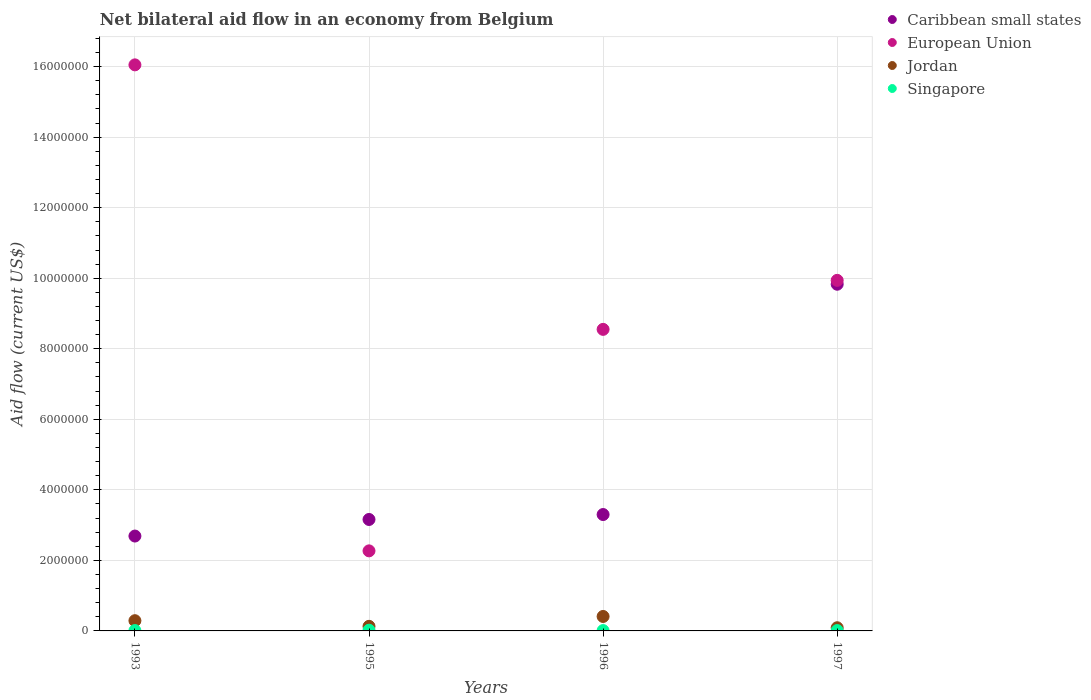What is the net bilateral aid flow in Caribbean small states in 1996?
Your answer should be compact. 3.30e+06. Across all years, what is the minimum net bilateral aid flow in Caribbean small states?
Keep it short and to the point. 2.69e+06. In which year was the net bilateral aid flow in Singapore maximum?
Keep it short and to the point. 1995. What is the total net bilateral aid flow in European Union in the graph?
Ensure brevity in your answer.  3.68e+07. What is the difference between the net bilateral aid flow in Singapore in 1996 and that in 1997?
Your answer should be compact. 0. What is the average net bilateral aid flow in European Union per year?
Offer a very short reply. 9.20e+06. In the year 1996, what is the difference between the net bilateral aid flow in Jordan and net bilateral aid flow in Singapore?
Keep it short and to the point. 4.00e+05. In how many years, is the net bilateral aid flow in Caribbean small states greater than 14800000 US$?
Keep it short and to the point. 0. What is the ratio of the net bilateral aid flow in Caribbean small states in 1993 to that in 1997?
Offer a very short reply. 0.27. What is the difference between the highest and the second highest net bilateral aid flow in Singapore?
Ensure brevity in your answer.  10000. What is the difference between the highest and the lowest net bilateral aid flow in Singapore?
Your response must be concise. 10000. In how many years, is the net bilateral aid flow in Singapore greater than the average net bilateral aid flow in Singapore taken over all years?
Your response must be concise. 1. Is it the case that in every year, the sum of the net bilateral aid flow in Jordan and net bilateral aid flow in Caribbean small states  is greater than the net bilateral aid flow in European Union?
Provide a short and direct response. No. Is the net bilateral aid flow in Jordan strictly greater than the net bilateral aid flow in Singapore over the years?
Offer a very short reply. Yes. Is the net bilateral aid flow in European Union strictly less than the net bilateral aid flow in Jordan over the years?
Offer a terse response. No. How many dotlines are there?
Offer a very short reply. 4. How many years are there in the graph?
Your answer should be compact. 4. What is the difference between two consecutive major ticks on the Y-axis?
Provide a short and direct response. 2.00e+06. Are the values on the major ticks of Y-axis written in scientific E-notation?
Provide a short and direct response. No. Does the graph contain any zero values?
Give a very brief answer. No. Where does the legend appear in the graph?
Your answer should be compact. Top right. How many legend labels are there?
Keep it short and to the point. 4. How are the legend labels stacked?
Provide a succinct answer. Vertical. What is the title of the graph?
Offer a very short reply. Net bilateral aid flow in an economy from Belgium. What is the label or title of the X-axis?
Give a very brief answer. Years. What is the Aid flow (current US$) in Caribbean small states in 1993?
Your answer should be very brief. 2.69e+06. What is the Aid flow (current US$) in European Union in 1993?
Ensure brevity in your answer.  1.60e+07. What is the Aid flow (current US$) in Jordan in 1993?
Provide a succinct answer. 2.90e+05. What is the Aid flow (current US$) of Singapore in 1993?
Provide a short and direct response. 10000. What is the Aid flow (current US$) in Caribbean small states in 1995?
Your answer should be compact. 3.16e+06. What is the Aid flow (current US$) in European Union in 1995?
Keep it short and to the point. 2.27e+06. What is the Aid flow (current US$) of Jordan in 1995?
Offer a terse response. 1.30e+05. What is the Aid flow (current US$) of Caribbean small states in 1996?
Give a very brief answer. 3.30e+06. What is the Aid flow (current US$) in European Union in 1996?
Provide a short and direct response. 8.55e+06. What is the Aid flow (current US$) in Caribbean small states in 1997?
Make the answer very short. 9.83e+06. What is the Aid flow (current US$) in European Union in 1997?
Give a very brief answer. 9.94e+06. What is the Aid flow (current US$) in Singapore in 1997?
Provide a short and direct response. 10000. Across all years, what is the maximum Aid flow (current US$) of Caribbean small states?
Provide a short and direct response. 9.83e+06. Across all years, what is the maximum Aid flow (current US$) in European Union?
Offer a very short reply. 1.60e+07. Across all years, what is the minimum Aid flow (current US$) of Caribbean small states?
Provide a short and direct response. 2.69e+06. Across all years, what is the minimum Aid flow (current US$) of European Union?
Your response must be concise. 2.27e+06. Across all years, what is the minimum Aid flow (current US$) in Singapore?
Ensure brevity in your answer.  10000. What is the total Aid flow (current US$) of Caribbean small states in the graph?
Your answer should be very brief. 1.90e+07. What is the total Aid flow (current US$) of European Union in the graph?
Make the answer very short. 3.68e+07. What is the total Aid flow (current US$) of Jordan in the graph?
Offer a very short reply. 9.20e+05. What is the difference between the Aid flow (current US$) in Caribbean small states in 1993 and that in 1995?
Your answer should be compact. -4.70e+05. What is the difference between the Aid flow (current US$) in European Union in 1993 and that in 1995?
Give a very brief answer. 1.38e+07. What is the difference between the Aid flow (current US$) of Jordan in 1993 and that in 1995?
Ensure brevity in your answer.  1.60e+05. What is the difference between the Aid flow (current US$) of Singapore in 1993 and that in 1995?
Your response must be concise. -10000. What is the difference between the Aid flow (current US$) in Caribbean small states in 1993 and that in 1996?
Ensure brevity in your answer.  -6.10e+05. What is the difference between the Aid flow (current US$) of European Union in 1993 and that in 1996?
Your answer should be compact. 7.50e+06. What is the difference between the Aid flow (current US$) in Jordan in 1993 and that in 1996?
Offer a terse response. -1.20e+05. What is the difference between the Aid flow (current US$) in Caribbean small states in 1993 and that in 1997?
Offer a very short reply. -7.14e+06. What is the difference between the Aid flow (current US$) of European Union in 1993 and that in 1997?
Make the answer very short. 6.11e+06. What is the difference between the Aid flow (current US$) of Caribbean small states in 1995 and that in 1996?
Offer a terse response. -1.40e+05. What is the difference between the Aid flow (current US$) in European Union in 1995 and that in 1996?
Provide a short and direct response. -6.28e+06. What is the difference between the Aid flow (current US$) of Jordan in 1995 and that in 1996?
Provide a succinct answer. -2.80e+05. What is the difference between the Aid flow (current US$) in Caribbean small states in 1995 and that in 1997?
Your answer should be compact. -6.67e+06. What is the difference between the Aid flow (current US$) of European Union in 1995 and that in 1997?
Provide a short and direct response. -7.67e+06. What is the difference between the Aid flow (current US$) of Jordan in 1995 and that in 1997?
Provide a succinct answer. 4.00e+04. What is the difference between the Aid flow (current US$) in Singapore in 1995 and that in 1997?
Ensure brevity in your answer.  10000. What is the difference between the Aid flow (current US$) of Caribbean small states in 1996 and that in 1997?
Make the answer very short. -6.53e+06. What is the difference between the Aid flow (current US$) in European Union in 1996 and that in 1997?
Keep it short and to the point. -1.39e+06. What is the difference between the Aid flow (current US$) in Singapore in 1996 and that in 1997?
Give a very brief answer. 0. What is the difference between the Aid flow (current US$) of Caribbean small states in 1993 and the Aid flow (current US$) of Jordan in 1995?
Your answer should be compact. 2.56e+06. What is the difference between the Aid flow (current US$) in Caribbean small states in 1993 and the Aid flow (current US$) in Singapore in 1995?
Ensure brevity in your answer.  2.67e+06. What is the difference between the Aid flow (current US$) in European Union in 1993 and the Aid flow (current US$) in Jordan in 1995?
Provide a short and direct response. 1.59e+07. What is the difference between the Aid flow (current US$) of European Union in 1993 and the Aid flow (current US$) of Singapore in 1995?
Your answer should be very brief. 1.60e+07. What is the difference between the Aid flow (current US$) of Jordan in 1993 and the Aid flow (current US$) of Singapore in 1995?
Provide a succinct answer. 2.70e+05. What is the difference between the Aid flow (current US$) in Caribbean small states in 1993 and the Aid flow (current US$) in European Union in 1996?
Offer a very short reply. -5.86e+06. What is the difference between the Aid flow (current US$) in Caribbean small states in 1993 and the Aid flow (current US$) in Jordan in 1996?
Your answer should be compact. 2.28e+06. What is the difference between the Aid flow (current US$) in Caribbean small states in 1993 and the Aid flow (current US$) in Singapore in 1996?
Your response must be concise. 2.68e+06. What is the difference between the Aid flow (current US$) in European Union in 1993 and the Aid flow (current US$) in Jordan in 1996?
Your answer should be very brief. 1.56e+07. What is the difference between the Aid flow (current US$) in European Union in 1993 and the Aid flow (current US$) in Singapore in 1996?
Keep it short and to the point. 1.60e+07. What is the difference between the Aid flow (current US$) of Caribbean small states in 1993 and the Aid flow (current US$) of European Union in 1997?
Your answer should be very brief. -7.25e+06. What is the difference between the Aid flow (current US$) of Caribbean small states in 1993 and the Aid flow (current US$) of Jordan in 1997?
Provide a short and direct response. 2.60e+06. What is the difference between the Aid flow (current US$) of Caribbean small states in 1993 and the Aid flow (current US$) of Singapore in 1997?
Provide a succinct answer. 2.68e+06. What is the difference between the Aid flow (current US$) in European Union in 1993 and the Aid flow (current US$) in Jordan in 1997?
Provide a short and direct response. 1.60e+07. What is the difference between the Aid flow (current US$) in European Union in 1993 and the Aid flow (current US$) in Singapore in 1997?
Ensure brevity in your answer.  1.60e+07. What is the difference between the Aid flow (current US$) of Caribbean small states in 1995 and the Aid flow (current US$) of European Union in 1996?
Keep it short and to the point. -5.39e+06. What is the difference between the Aid flow (current US$) in Caribbean small states in 1995 and the Aid flow (current US$) in Jordan in 1996?
Provide a succinct answer. 2.75e+06. What is the difference between the Aid flow (current US$) of Caribbean small states in 1995 and the Aid flow (current US$) of Singapore in 1996?
Your response must be concise. 3.15e+06. What is the difference between the Aid flow (current US$) in European Union in 1995 and the Aid flow (current US$) in Jordan in 1996?
Your response must be concise. 1.86e+06. What is the difference between the Aid flow (current US$) in European Union in 1995 and the Aid flow (current US$) in Singapore in 1996?
Provide a succinct answer. 2.26e+06. What is the difference between the Aid flow (current US$) of Caribbean small states in 1995 and the Aid flow (current US$) of European Union in 1997?
Your answer should be compact. -6.78e+06. What is the difference between the Aid flow (current US$) of Caribbean small states in 1995 and the Aid flow (current US$) of Jordan in 1997?
Give a very brief answer. 3.07e+06. What is the difference between the Aid flow (current US$) of Caribbean small states in 1995 and the Aid flow (current US$) of Singapore in 1997?
Offer a terse response. 3.15e+06. What is the difference between the Aid flow (current US$) in European Union in 1995 and the Aid flow (current US$) in Jordan in 1997?
Your response must be concise. 2.18e+06. What is the difference between the Aid flow (current US$) in European Union in 1995 and the Aid flow (current US$) in Singapore in 1997?
Provide a succinct answer. 2.26e+06. What is the difference between the Aid flow (current US$) of Caribbean small states in 1996 and the Aid flow (current US$) of European Union in 1997?
Ensure brevity in your answer.  -6.64e+06. What is the difference between the Aid flow (current US$) in Caribbean small states in 1996 and the Aid flow (current US$) in Jordan in 1997?
Provide a succinct answer. 3.21e+06. What is the difference between the Aid flow (current US$) in Caribbean small states in 1996 and the Aid flow (current US$) in Singapore in 1997?
Your answer should be compact. 3.29e+06. What is the difference between the Aid flow (current US$) of European Union in 1996 and the Aid flow (current US$) of Jordan in 1997?
Your answer should be very brief. 8.46e+06. What is the difference between the Aid flow (current US$) of European Union in 1996 and the Aid flow (current US$) of Singapore in 1997?
Offer a terse response. 8.54e+06. What is the average Aid flow (current US$) in Caribbean small states per year?
Ensure brevity in your answer.  4.74e+06. What is the average Aid flow (current US$) in European Union per year?
Provide a succinct answer. 9.20e+06. What is the average Aid flow (current US$) of Singapore per year?
Keep it short and to the point. 1.25e+04. In the year 1993, what is the difference between the Aid flow (current US$) of Caribbean small states and Aid flow (current US$) of European Union?
Your response must be concise. -1.34e+07. In the year 1993, what is the difference between the Aid flow (current US$) of Caribbean small states and Aid flow (current US$) of Jordan?
Your response must be concise. 2.40e+06. In the year 1993, what is the difference between the Aid flow (current US$) in Caribbean small states and Aid flow (current US$) in Singapore?
Offer a very short reply. 2.68e+06. In the year 1993, what is the difference between the Aid flow (current US$) of European Union and Aid flow (current US$) of Jordan?
Give a very brief answer. 1.58e+07. In the year 1993, what is the difference between the Aid flow (current US$) of European Union and Aid flow (current US$) of Singapore?
Ensure brevity in your answer.  1.60e+07. In the year 1995, what is the difference between the Aid flow (current US$) of Caribbean small states and Aid flow (current US$) of European Union?
Keep it short and to the point. 8.90e+05. In the year 1995, what is the difference between the Aid flow (current US$) of Caribbean small states and Aid flow (current US$) of Jordan?
Give a very brief answer. 3.03e+06. In the year 1995, what is the difference between the Aid flow (current US$) in Caribbean small states and Aid flow (current US$) in Singapore?
Your answer should be very brief. 3.14e+06. In the year 1995, what is the difference between the Aid flow (current US$) in European Union and Aid flow (current US$) in Jordan?
Ensure brevity in your answer.  2.14e+06. In the year 1995, what is the difference between the Aid flow (current US$) in European Union and Aid flow (current US$) in Singapore?
Your response must be concise. 2.25e+06. In the year 1996, what is the difference between the Aid flow (current US$) in Caribbean small states and Aid flow (current US$) in European Union?
Ensure brevity in your answer.  -5.25e+06. In the year 1996, what is the difference between the Aid flow (current US$) in Caribbean small states and Aid flow (current US$) in Jordan?
Give a very brief answer. 2.89e+06. In the year 1996, what is the difference between the Aid flow (current US$) in Caribbean small states and Aid flow (current US$) in Singapore?
Offer a very short reply. 3.29e+06. In the year 1996, what is the difference between the Aid flow (current US$) of European Union and Aid flow (current US$) of Jordan?
Make the answer very short. 8.14e+06. In the year 1996, what is the difference between the Aid flow (current US$) in European Union and Aid flow (current US$) in Singapore?
Keep it short and to the point. 8.54e+06. In the year 1997, what is the difference between the Aid flow (current US$) in Caribbean small states and Aid flow (current US$) in Jordan?
Offer a very short reply. 9.74e+06. In the year 1997, what is the difference between the Aid flow (current US$) in Caribbean small states and Aid flow (current US$) in Singapore?
Provide a short and direct response. 9.82e+06. In the year 1997, what is the difference between the Aid flow (current US$) of European Union and Aid flow (current US$) of Jordan?
Your answer should be compact. 9.85e+06. In the year 1997, what is the difference between the Aid flow (current US$) in European Union and Aid flow (current US$) in Singapore?
Provide a succinct answer. 9.93e+06. In the year 1997, what is the difference between the Aid flow (current US$) of Jordan and Aid flow (current US$) of Singapore?
Ensure brevity in your answer.  8.00e+04. What is the ratio of the Aid flow (current US$) of Caribbean small states in 1993 to that in 1995?
Provide a short and direct response. 0.85. What is the ratio of the Aid flow (current US$) in European Union in 1993 to that in 1995?
Provide a short and direct response. 7.07. What is the ratio of the Aid flow (current US$) in Jordan in 1993 to that in 1995?
Your answer should be very brief. 2.23. What is the ratio of the Aid flow (current US$) of Singapore in 1993 to that in 1995?
Offer a very short reply. 0.5. What is the ratio of the Aid flow (current US$) in Caribbean small states in 1993 to that in 1996?
Provide a succinct answer. 0.82. What is the ratio of the Aid flow (current US$) in European Union in 1993 to that in 1996?
Your response must be concise. 1.88. What is the ratio of the Aid flow (current US$) in Jordan in 1993 to that in 1996?
Offer a terse response. 0.71. What is the ratio of the Aid flow (current US$) in Singapore in 1993 to that in 1996?
Give a very brief answer. 1. What is the ratio of the Aid flow (current US$) of Caribbean small states in 1993 to that in 1997?
Give a very brief answer. 0.27. What is the ratio of the Aid flow (current US$) of European Union in 1993 to that in 1997?
Provide a succinct answer. 1.61. What is the ratio of the Aid flow (current US$) in Jordan in 1993 to that in 1997?
Your answer should be compact. 3.22. What is the ratio of the Aid flow (current US$) of Caribbean small states in 1995 to that in 1996?
Keep it short and to the point. 0.96. What is the ratio of the Aid flow (current US$) in European Union in 1995 to that in 1996?
Your answer should be very brief. 0.27. What is the ratio of the Aid flow (current US$) in Jordan in 1995 to that in 1996?
Keep it short and to the point. 0.32. What is the ratio of the Aid flow (current US$) of Singapore in 1995 to that in 1996?
Give a very brief answer. 2. What is the ratio of the Aid flow (current US$) in Caribbean small states in 1995 to that in 1997?
Your answer should be very brief. 0.32. What is the ratio of the Aid flow (current US$) of European Union in 1995 to that in 1997?
Offer a terse response. 0.23. What is the ratio of the Aid flow (current US$) of Jordan in 1995 to that in 1997?
Ensure brevity in your answer.  1.44. What is the ratio of the Aid flow (current US$) in Singapore in 1995 to that in 1997?
Ensure brevity in your answer.  2. What is the ratio of the Aid flow (current US$) in Caribbean small states in 1996 to that in 1997?
Ensure brevity in your answer.  0.34. What is the ratio of the Aid flow (current US$) of European Union in 1996 to that in 1997?
Your response must be concise. 0.86. What is the ratio of the Aid flow (current US$) of Jordan in 1996 to that in 1997?
Your response must be concise. 4.56. What is the ratio of the Aid flow (current US$) in Singapore in 1996 to that in 1997?
Your answer should be compact. 1. What is the difference between the highest and the second highest Aid flow (current US$) of Caribbean small states?
Make the answer very short. 6.53e+06. What is the difference between the highest and the second highest Aid flow (current US$) in European Union?
Offer a terse response. 6.11e+06. What is the difference between the highest and the second highest Aid flow (current US$) in Jordan?
Ensure brevity in your answer.  1.20e+05. What is the difference between the highest and the second highest Aid flow (current US$) in Singapore?
Provide a short and direct response. 10000. What is the difference between the highest and the lowest Aid flow (current US$) of Caribbean small states?
Offer a very short reply. 7.14e+06. What is the difference between the highest and the lowest Aid flow (current US$) of European Union?
Give a very brief answer. 1.38e+07. What is the difference between the highest and the lowest Aid flow (current US$) in Singapore?
Your answer should be very brief. 10000. 